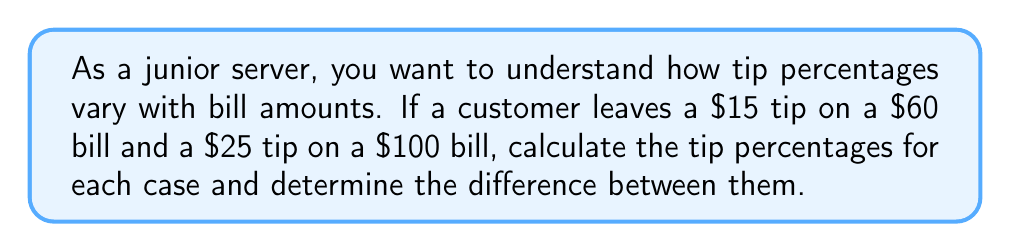Help me with this question. Let's approach this step-by-step:

1. Calculate the tip percentage for the $60 bill:
   Tip percentage = (Tip amount / Bill amount) × 100%
   $$ \text{Tip percentage}_1 = \frac{\$15}{\$60} \times 100\% = 0.25 \times 100\% = 25\% $$

2. Calculate the tip percentage for the $100 bill:
   $$ \text{Tip percentage}_2 = \frac{\$25}{\$100} \times 100\% = 0.25 \times 100\% = 25\% $$

3. Calculate the difference between the two tip percentages:
   $$ \text{Difference} = |\text{Tip percentage}_2 - \text{Tip percentage}_1| = |25\% - 25\%| = 0\% $$

In this case, we find that the tip percentages are the same for both bills, despite the different amounts. This demonstrates that the customers maintained a consistent tipping rate regardless of the bill size.
Answer: 25% for both; 0% difference 